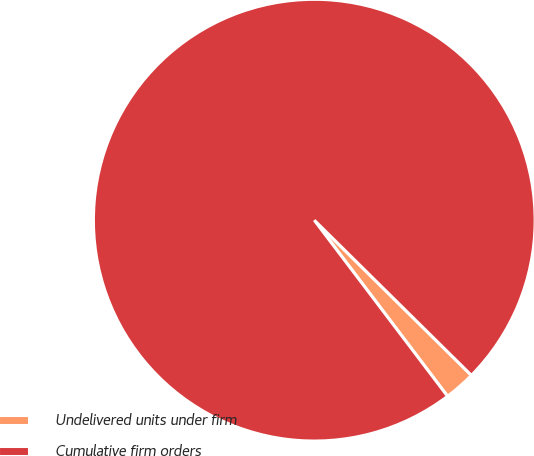Convert chart. <chart><loc_0><loc_0><loc_500><loc_500><pie_chart><fcel>Undelivered units under firm<fcel>Cumulative firm orders<nl><fcel>2.29%<fcel>97.71%<nl></chart> 